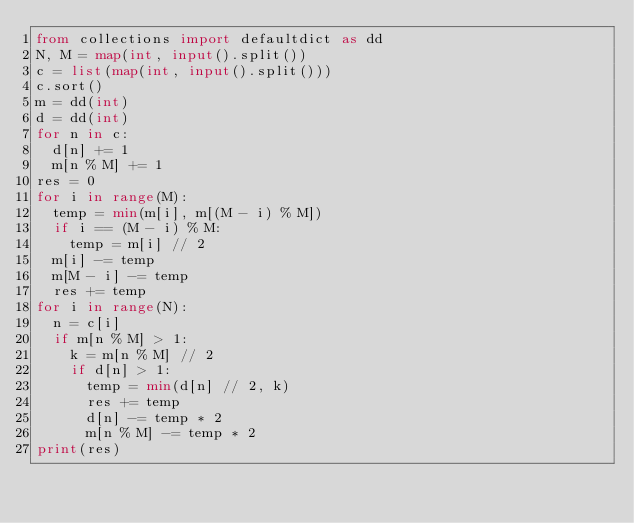Convert code to text. <code><loc_0><loc_0><loc_500><loc_500><_Python_>from collections import defaultdict as dd
N, M = map(int, input().split())
c = list(map(int, input().split()))
c.sort()
m = dd(int)
d = dd(int)
for n in c:
  d[n] += 1
  m[n % M] += 1
res = 0
for i in range(M):
  temp = min(m[i], m[(M - i) % M])
  if i == (M - i) % M:
    temp = m[i] // 2
  m[i] -= temp
  m[M - i] -= temp
  res += temp
for i in range(N):
  n = c[i]
  if m[n % M] > 1:
    k = m[n % M] // 2
    if d[n] > 1:
      temp = min(d[n] // 2, k)
      res += temp
      d[n] -= temp * 2
      m[n % M] -= temp * 2
print(res)</code> 